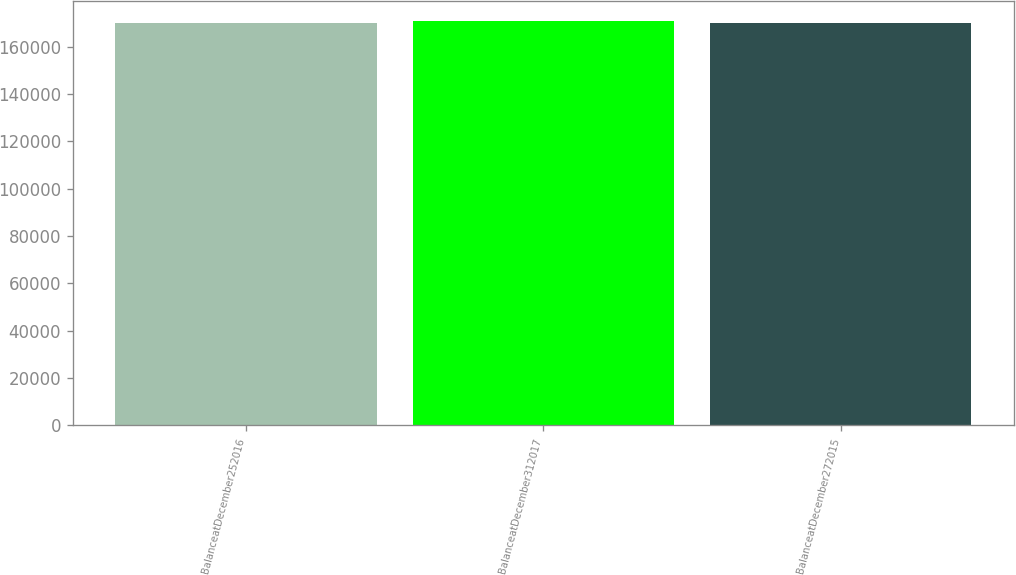<chart> <loc_0><loc_0><loc_500><loc_500><bar_chart><fcel>BalanceatDecember252016<fcel>BalanceatDecember312017<fcel>BalanceatDecember272015<nl><fcel>169833<fcel>170699<fcel>170110<nl></chart> 